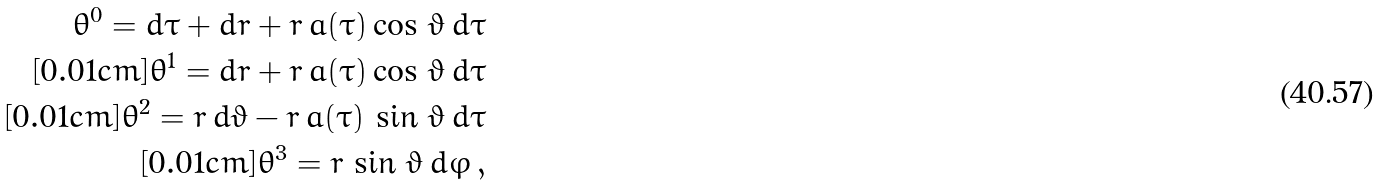Convert formula to latex. <formula><loc_0><loc_0><loc_500><loc_500>\theta ^ { 0 } = d \tau + d r + r \, a ( \tau ) \cos \, \vartheta \, d \tau \\ [ 0 . 0 1 c m ] \theta ^ { 1 } = d r + r \, a ( \tau ) \cos \, \vartheta \, d \tau \\ [ 0 . 0 1 c m ] \theta ^ { 2 } = r \, d \vartheta - r \, a ( \tau ) \, \sin \, \vartheta \, d \tau \\ [ 0 . 0 1 c m ] \theta ^ { 3 } = r \, \sin \, \vartheta \, d \varphi \, ,</formula> 